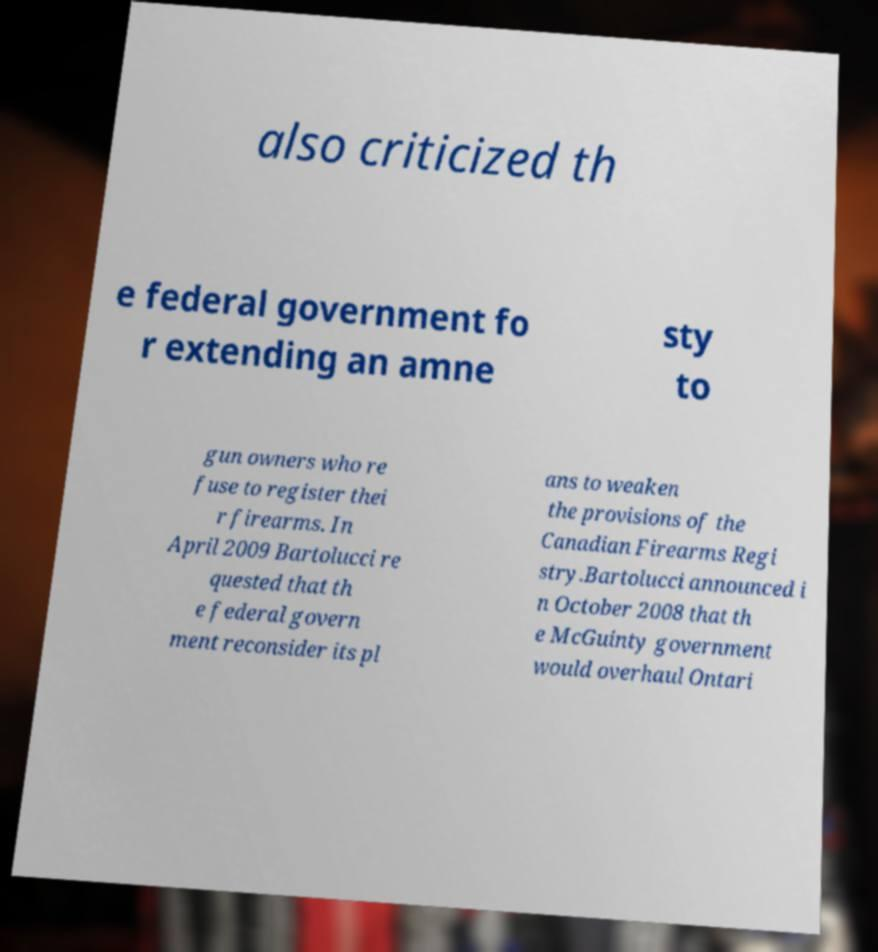I need the written content from this picture converted into text. Can you do that? also criticized th e federal government fo r extending an amne sty to gun owners who re fuse to register thei r firearms. In April 2009 Bartolucci re quested that th e federal govern ment reconsider its pl ans to weaken the provisions of the Canadian Firearms Regi stry.Bartolucci announced i n October 2008 that th e McGuinty government would overhaul Ontari 